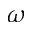<formula> <loc_0><loc_0><loc_500><loc_500>\omega</formula> 